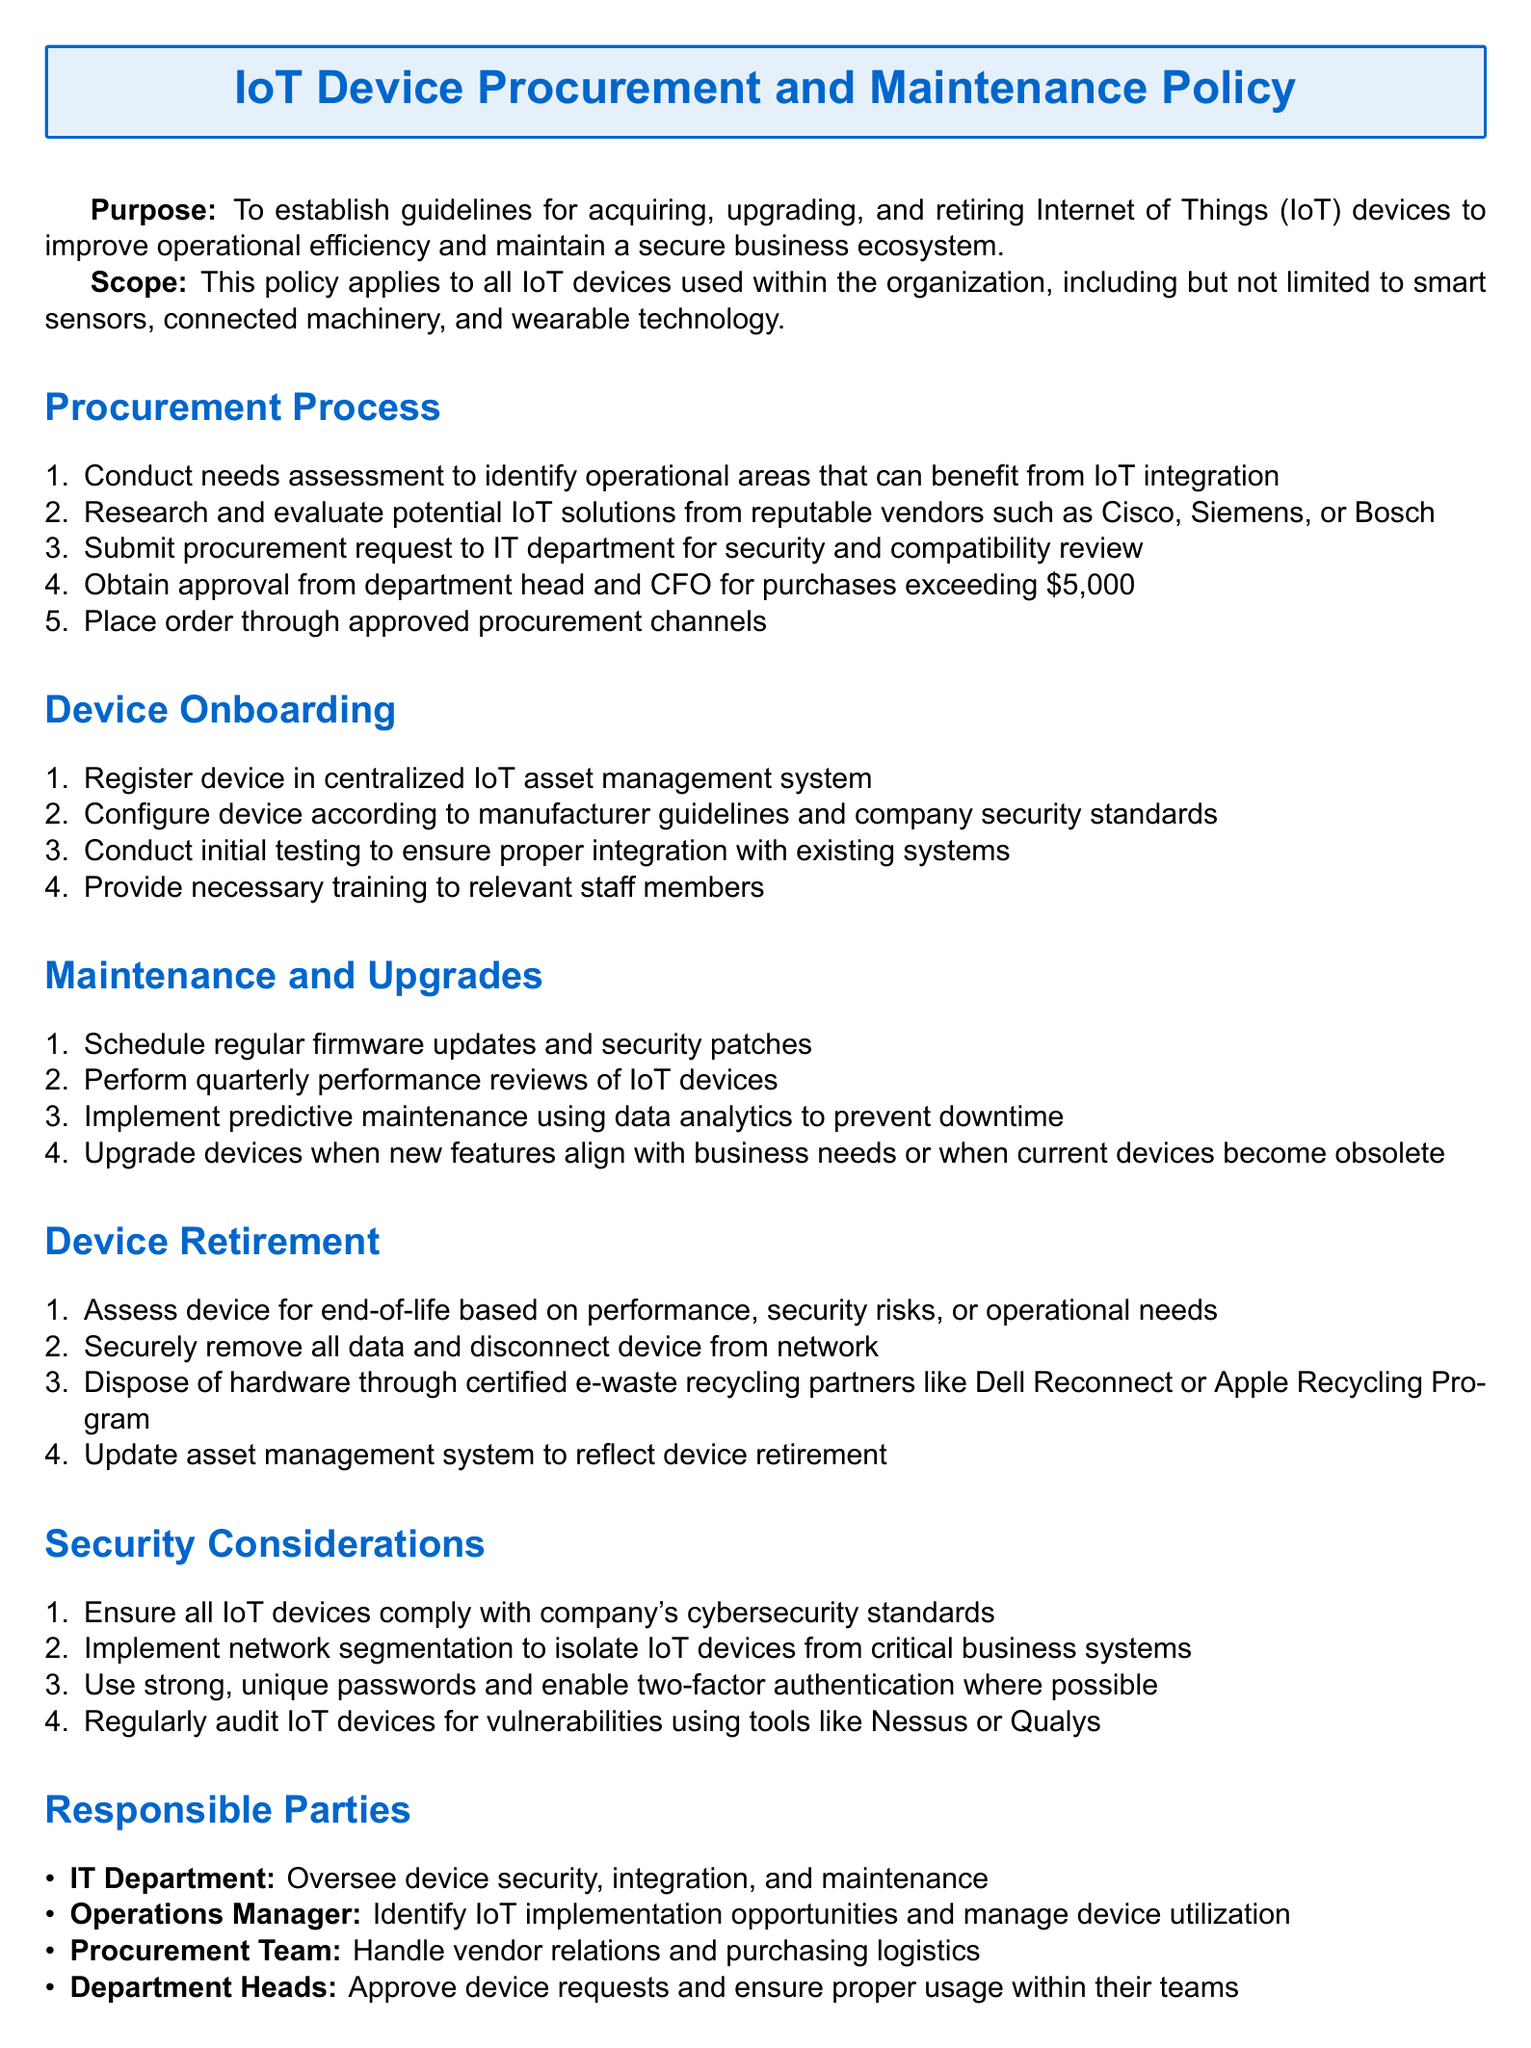What is the purpose of the document? The purpose is to establish guidelines for acquiring, upgrading, and retiring Internet of Things (IoT) devices.
Answer: To establish guidelines for acquiring, upgrading, and retiring Internet of Things (IoT) devices Which department reviews procurement requests for security and compatibility? The procurement request is submitted to the IT department for security and compatibility review.
Answer: IT department What is the minimum purchase amount that requires approval from the department head and CFO? The document states that purchases exceeding a certain amount require approval.
Answer: $5,000 What is conducted to ensure proper integration with existing systems? Initial testing is conducted to ensure proper integration with existing systems.
Answer: Initial testing How often should performance reviews of IoT devices be performed? The document specifies the frequency of performance reviews for IoT devices.
Answer: Quarterly What should be done with data from a device before retirement? The document states that all data should be securely removed before retiring a device.
Answer: Securely remove all data Who is responsible for identifying IoT implementation opportunities? This role is designated in the document to a specific position within the organization.
Answer: Operations Manager What key strategy is mentioned for preventing downtime in IoT devices? The document includes a strategy for preventing downtime in IoT devices that relies on data.
Answer: Predictive maintenance What must be done to ensure all IoT devices comply with? The document outlines compliance requirements for IoT devices.
Answer: Company's cybersecurity standards 